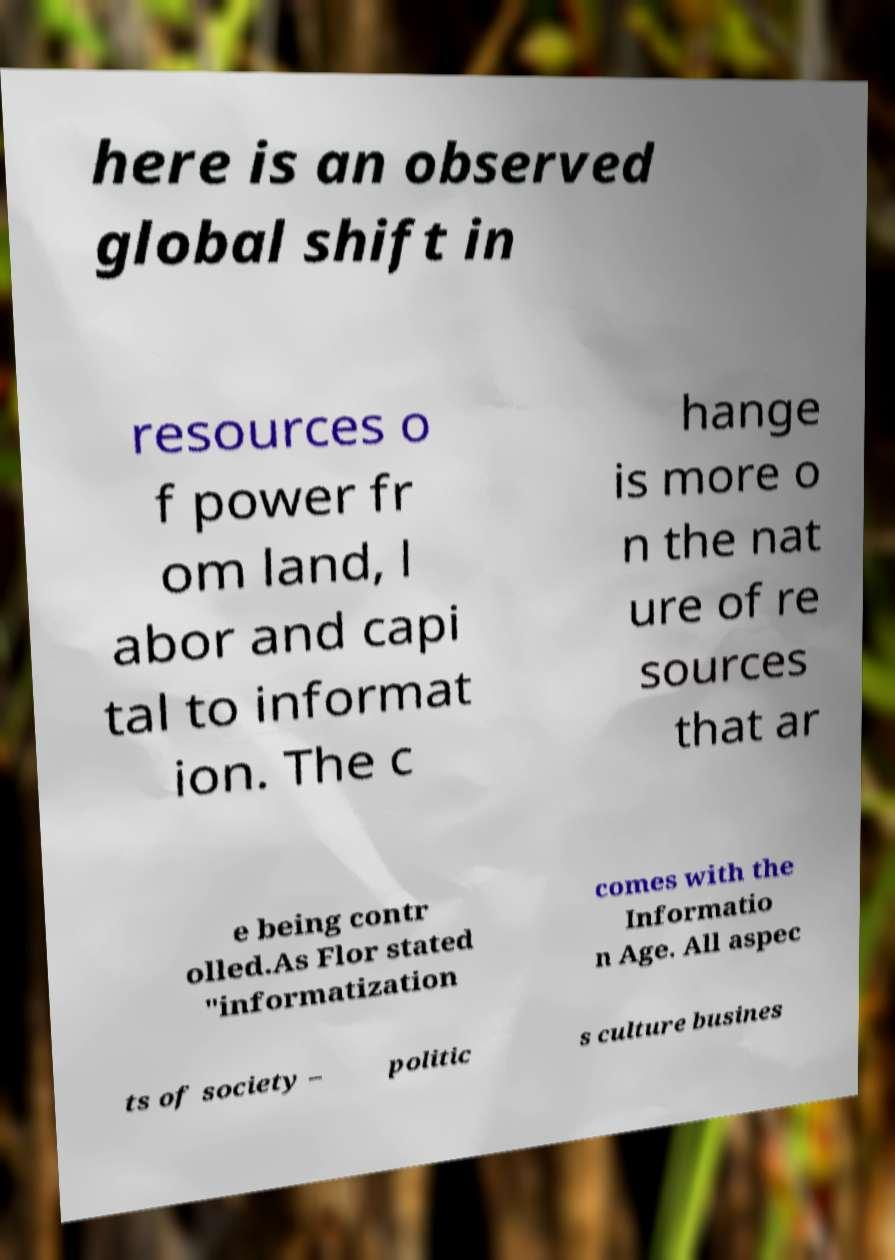I need the written content from this picture converted into text. Can you do that? here is an observed global shift in resources o f power fr om land, l abor and capi tal to informat ion. The c hange is more o n the nat ure of re sources that ar e being contr olled.As Flor stated "informatization comes with the Informatio n Age. All aspec ts of society – politic s culture busines 